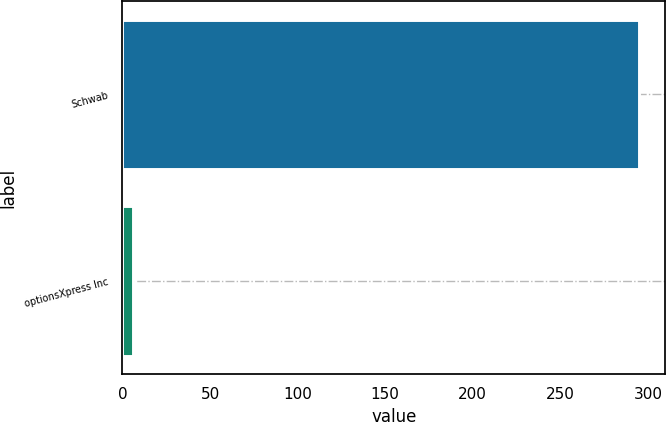<chart> <loc_0><loc_0><loc_500><loc_500><bar_chart><fcel>Schwab<fcel>optionsXpress Inc<nl><fcel>295<fcel>6<nl></chart> 